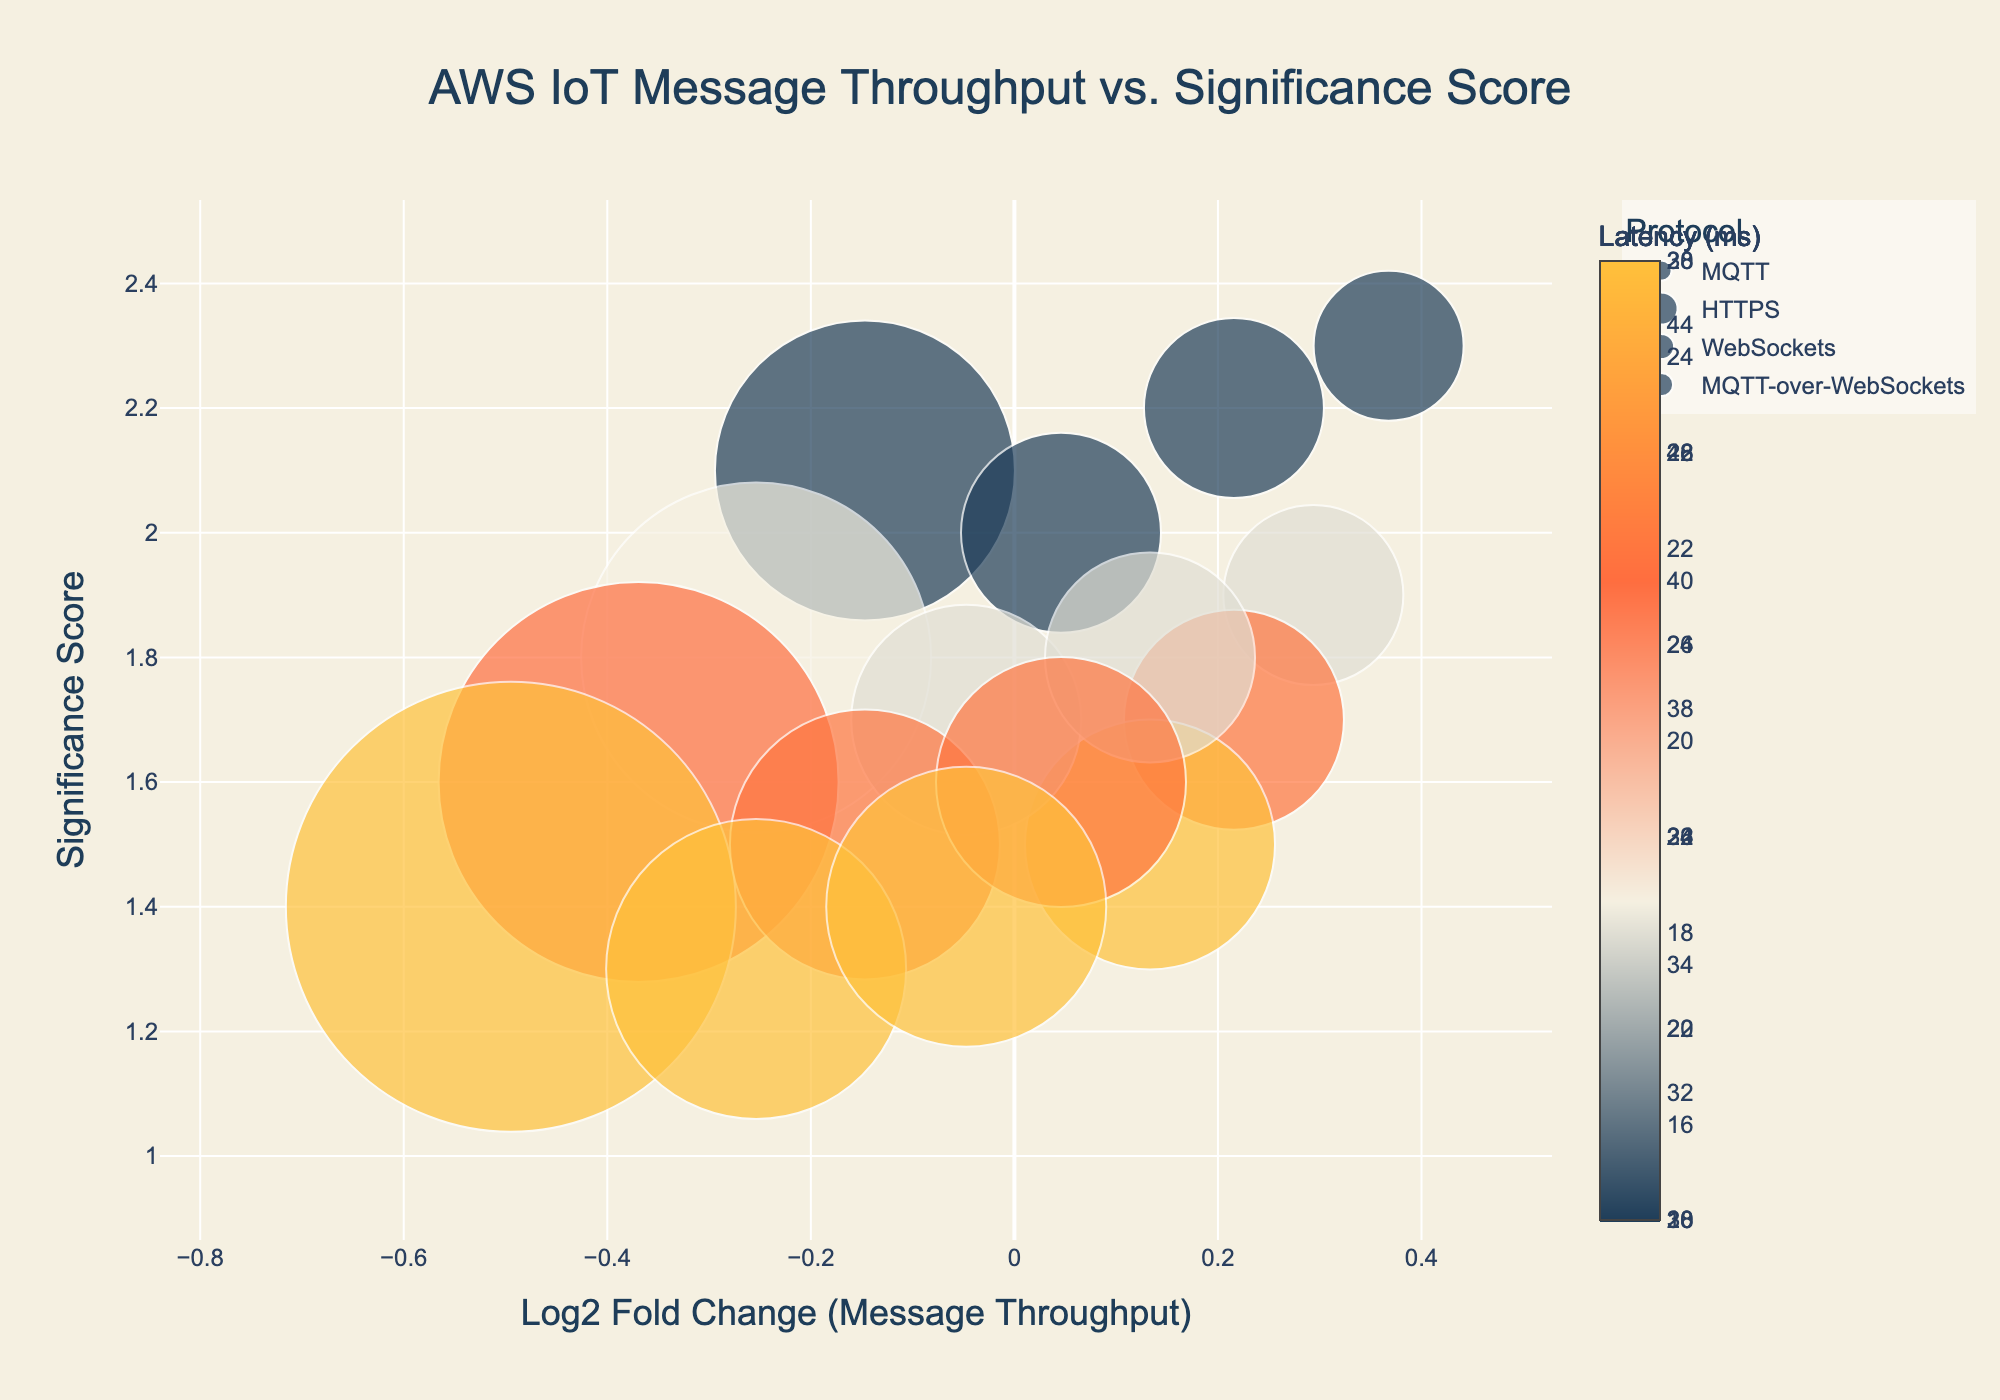What's the title of the plot? The title of the figure is clearly stated at the top of the plot. It reads "AWS IoT Message Throughput vs. Significance Score".
Answer: AWS IoT Message Throughput vs. Significance Score Which protocol has the highest significance score in the us-east-1 region? To determine this, we look at the markers corresponding to the us-east-1 region and compare their y-values. The protocol with the highest point on the y-axis has the highest significance score. The MQTT protocol has a significance score of 2.3, which is the highest.
Answer: MQTT How many protocols are represented in the plot? Each unique color in the legend represents a protocol. There are four different colors and names listed in the legend, so there are four protocols.
Answer: Four Which region has the highest latency for the MQTT protocol? First, identify the points corresponding to the MQTT protocol by looking at the color and legend. Then, among these points, find the one with the largest marker size since the marker size is proportional to latency. The ap-southeast-2 region has the largest marker size for the MQTT protocol, indicating the highest latency.
Answer: ap-southeast-2 What is the log2 fold change for the HTTPS protocol in the us-west-2 region? Locate the marker corresponding to the HTTPS protocol in the us-west-2 region. The x-coordinate of this marker represents the log2 fold change. The log2 fold change for this point is around -0.50.
Answer: -0.50 Which protocol generally has the highest significance scores? Review the markers for each protocol and observe their heights on the y-axis. The MQTT protocol consistently has the highest markers, indicating higher significance scores compared to the others.
Answer: MQTT Which region shows the lowest message throughput for the WebSockets protocol? Identify the markers for the WebSockets protocol by referring to the legend. Then, compare their x-coordinates to find the smallest log2 fold change since lower log2 fold change corresponds to lower throughput. The ap-southeast-2 marker is the lowest in x-value, indicating the lowest throughput.
Answer: ap-southeast-2 What is the relationship between latency and marker size in the plot? Marker size is directly proportional to latency; larger markers indicate higher latency. The size of each marker is determined by the latency value divided by 2.
Answer: Directly proportional Do any regions see a decrease in message throughput for the MQTT-over-WebSockets protocol compared to the average throughput? Calculate the average message throughput across all regions for reference, which is about (sum of all throughputs)/16. Then, use the log2 fold change values to identify the markers that show a decrease (negative log2 fold change). The ap-southeast-2 region for MQTT-over-WebSockets has a negative log2 fold change, indicating a decrease in throughput.
Answer: ap-southeast-2 